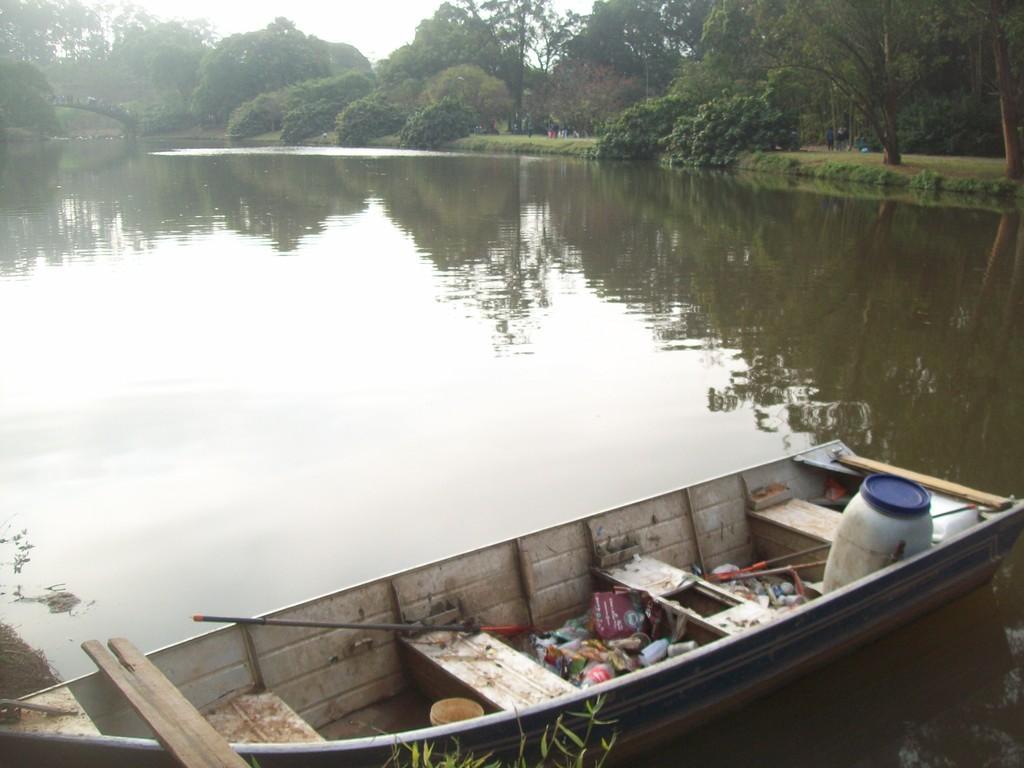Can you describe this image briefly? In this image I can see a boat on the water. On the boat I can see a drum and some other objects. In the background I can see trees and the sky. 